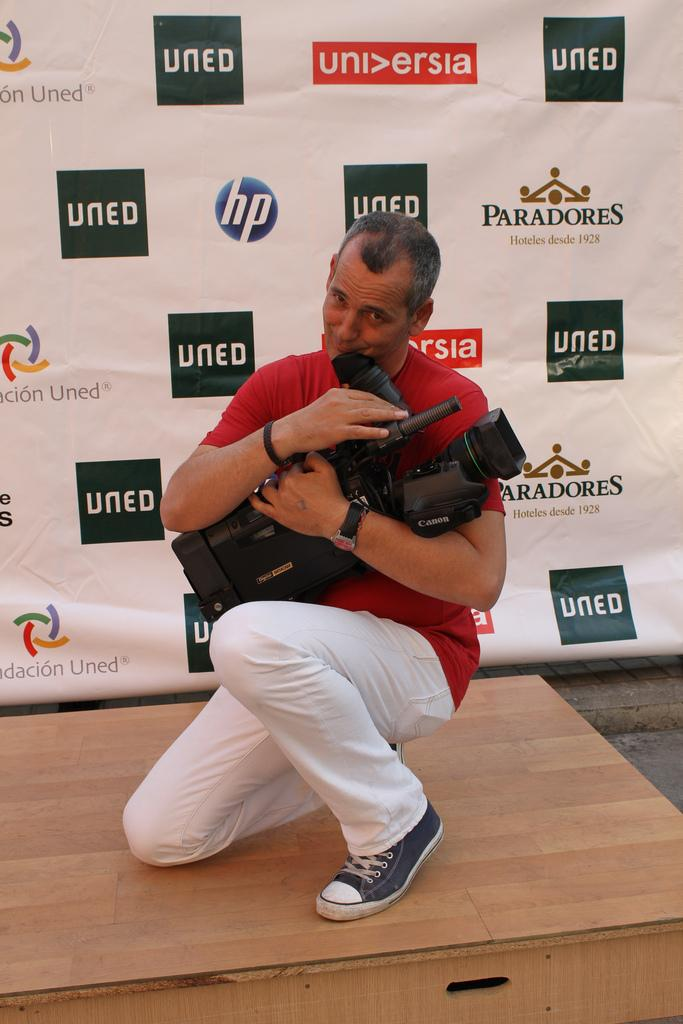<image>
Offer a succinct explanation of the picture presented. A cameraman hugging a large Canon camera on a wooden platform. 